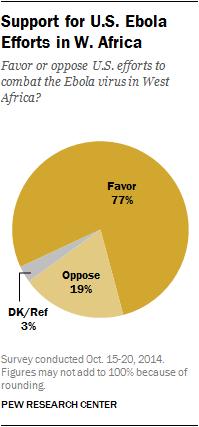Indicate a few pertinent items in this graphic. The Pie chart shows that the value of favor is the highest among the other options. The difference in value between "Oppose" and "DK/Ref" is 16%. 